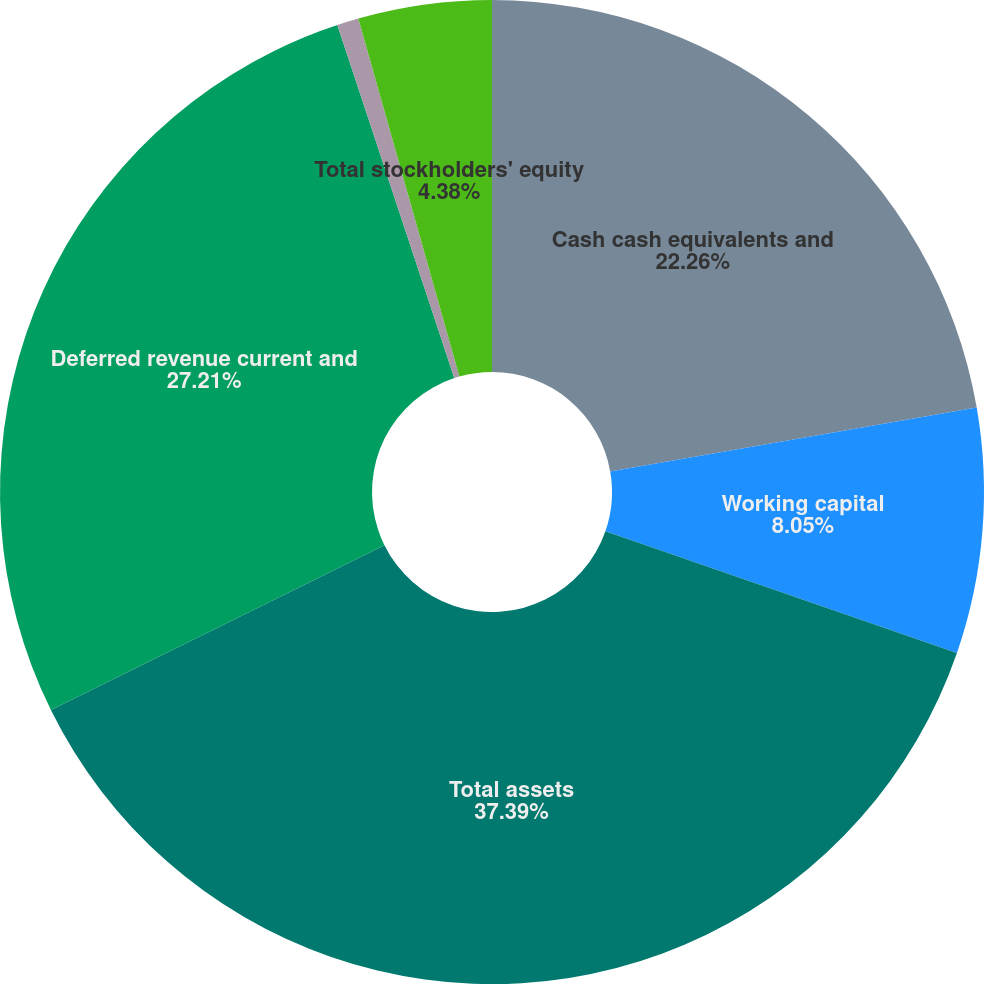Convert chart. <chart><loc_0><loc_0><loc_500><loc_500><pie_chart><fcel>Cash cash equivalents and<fcel>Working capital<fcel>Total assets<fcel>Deferred revenue current and<fcel>Common stock including<fcel>Total stockholders' equity<nl><fcel>22.26%<fcel>8.05%<fcel>37.4%<fcel>27.22%<fcel>0.71%<fcel>4.38%<nl></chart> 